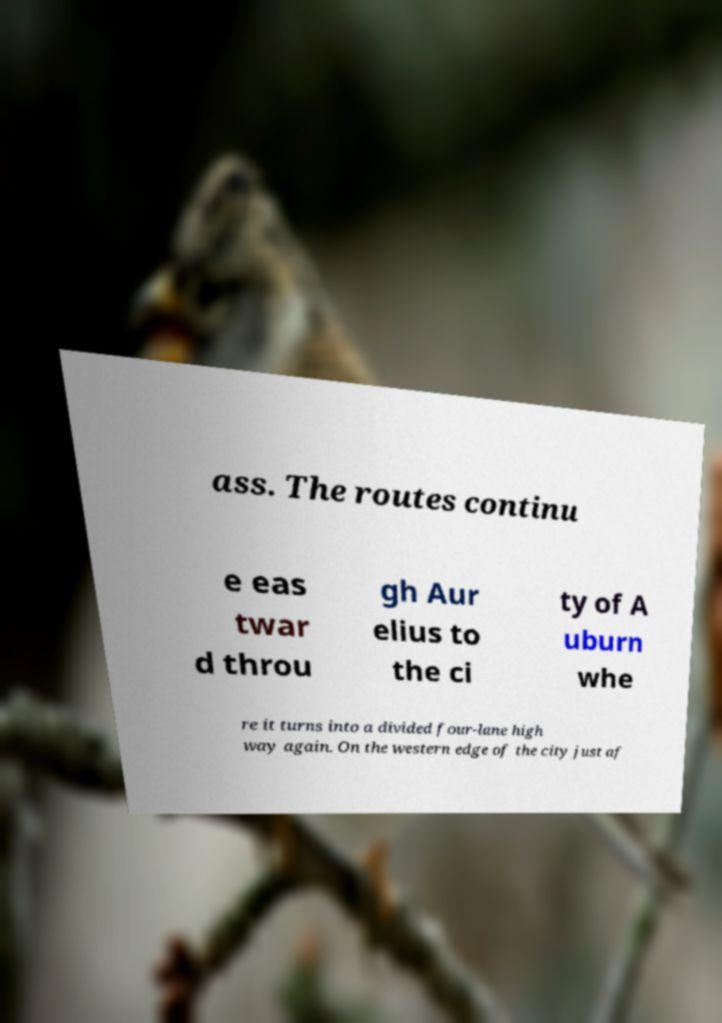Can you read and provide the text displayed in the image?This photo seems to have some interesting text. Can you extract and type it out for me? ass. The routes continu e eas twar d throu gh Aur elius to the ci ty of A uburn whe re it turns into a divided four-lane high way again. On the western edge of the city just af 